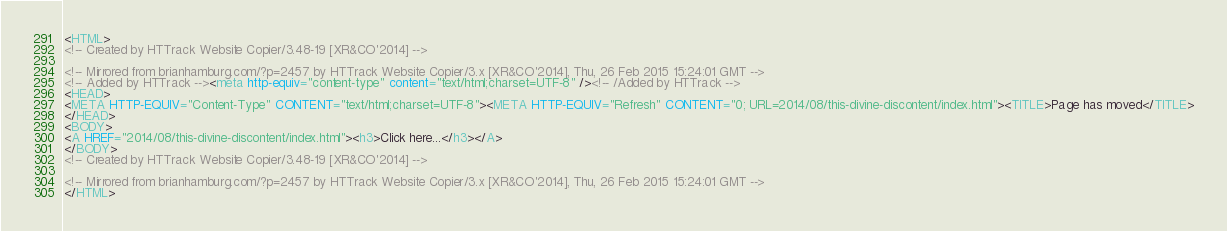Convert code to text. <code><loc_0><loc_0><loc_500><loc_500><_HTML_><HTML>
<!-- Created by HTTrack Website Copier/3.48-19 [XR&CO'2014] -->

<!-- Mirrored from brianhamburg.com/?p=2457 by HTTrack Website Copier/3.x [XR&CO'2014], Thu, 26 Feb 2015 15:24:01 GMT -->
<!-- Added by HTTrack --><meta http-equiv="content-type" content="text/html;charset=UTF-8" /><!-- /Added by HTTrack -->
<HEAD>
<META HTTP-EQUIV="Content-Type" CONTENT="text/html;charset=UTF-8"><META HTTP-EQUIV="Refresh" CONTENT="0; URL=2014/08/this-divine-discontent/index.html"><TITLE>Page has moved</TITLE>
</HEAD>
<BODY>
<A HREF="2014/08/this-divine-discontent/index.html"><h3>Click here...</h3></A>
</BODY>
<!-- Created by HTTrack Website Copier/3.48-19 [XR&CO'2014] -->

<!-- Mirrored from brianhamburg.com/?p=2457 by HTTrack Website Copier/3.x [XR&CO'2014], Thu, 26 Feb 2015 15:24:01 GMT -->
</HTML>
</code> 